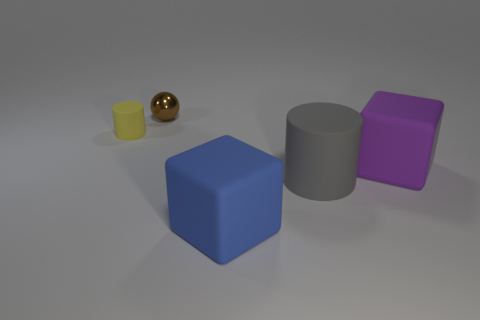What is the color of the rubber thing that is left of the brown object?
Keep it short and to the point. Yellow. There is a rubber cylinder in front of the small yellow cylinder; does it have the same color as the small sphere?
Offer a very short reply. No. What material is the blue thing that is the same shape as the purple thing?
Make the answer very short. Rubber. How many purple blocks have the same size as the gray matte cylinder?
Your answer should be very brief. 1. The purple thing has what shape?
Keep it short and to the point. Cube. There is a object that is both to the left of the blue object and on the right side of the tiny rubber thing; how big is it?
Your answer should be compact. Small. There is a object behind the small yellow rubber cylinder; what is its material?
Ensure brevity in your answer.  Metal. Is the color of the metallic ball the same as the rubber cube to the left of the large purple thing?
Provide a short and direct response. No. What is the color of the thing that is both to the left of the blue cube and in front of the brown sphere?
Your response must be concise. Yellow. There is a matte thing that is behind the big purple rubber thing; is it the same shape as the gray matte thing?
Make the answer very short. Yes. 